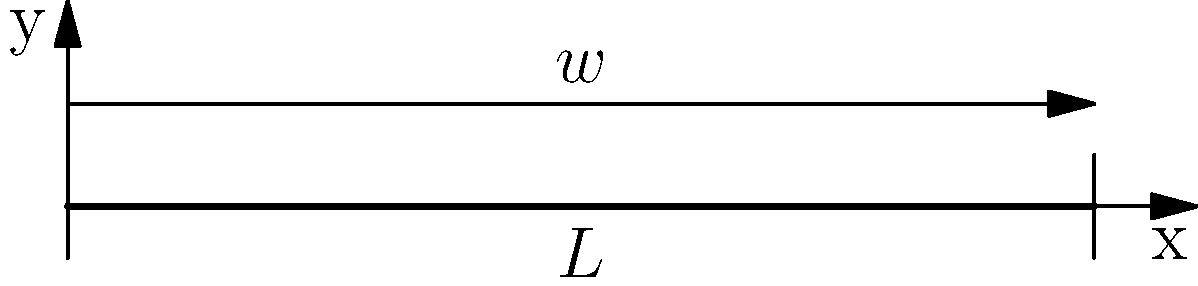A simply supported beam of length $L = 10$ m is subjected to a uniformly distributed load of $w = 5$ kN/m along its entire length, as shown in the diagram. Calculate the maximum bending stress in the beam if it has a rectangular cross-section with a width of 100 mm and a height of 200 mm. To find the maximum bending stress, we'll follow these steps:

1) Calculate the maximum bending moment:
   For a simply supported beam with uniformly distributed load, the maximum bending moment occurs at the center and is given by:
   $$M_{max} = \frac{wL^2}{8}$$
   $$M_{max} = \frac{5 \times 10^2}{8} = 62.5 \text{ kN·m}$$

2) Calculate the moment of inertia of the rectangular cross-section:
   $$I = \frac{bh^3}{12}$$
   where $b$ is the width and $h$ is the height
   $$I = \frac{0.1 \times 0.2^3}{12} = 6.67 \times 10^{-5} \text{ m}^4$$

3) Calculate the distance from the neutral axis to the extreme fiber:
   $$y = \frac{h}{2} = \frac{0.2}{2} = 0.1 \text{ m}$$

4) Use the flexure formula to calculate the maximum bending stress:
   $$\sigma_{max} = \frac{M_{max}y}{I}$$
   $$\sigma_{max} = \frac{62.5 \times 0.1}{6.67 \times 10^{-5}} = 93.7 \text{ MPa}$$
Answer: 93.7 MPa 